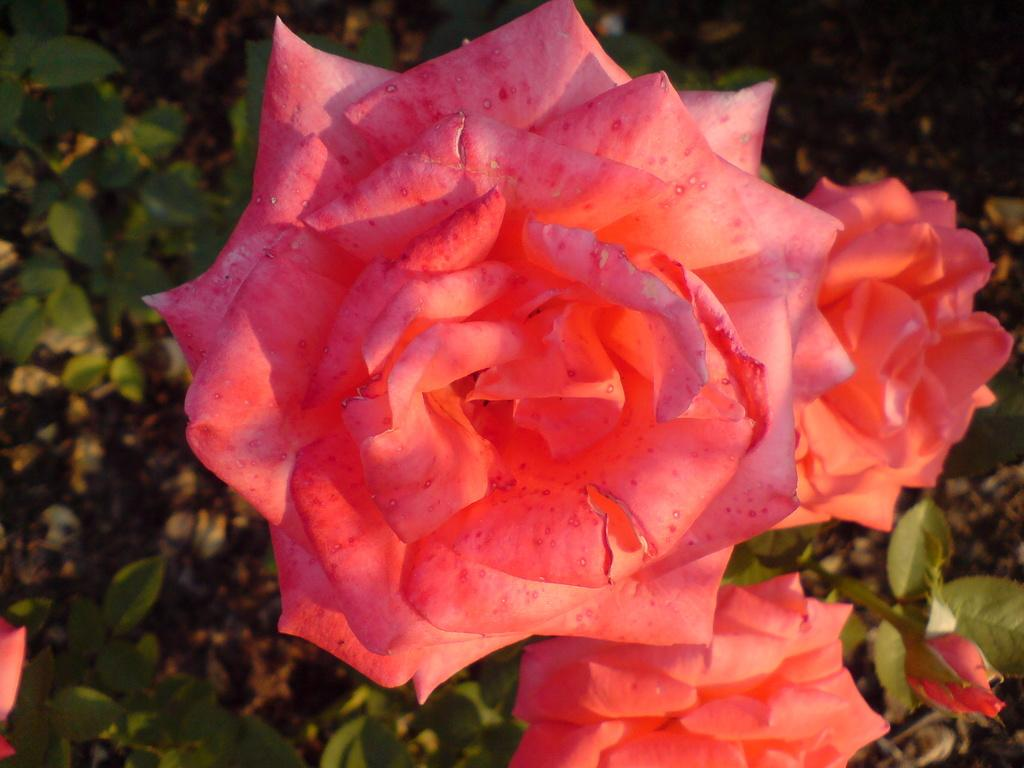What type of flora can be seen in the image? There are flowers and plants in the image. Can you describe the background of the image? The background of the image is visible. Can you taste the lake in the image? There is no lake present in the image, so it is not possible to taste it. 